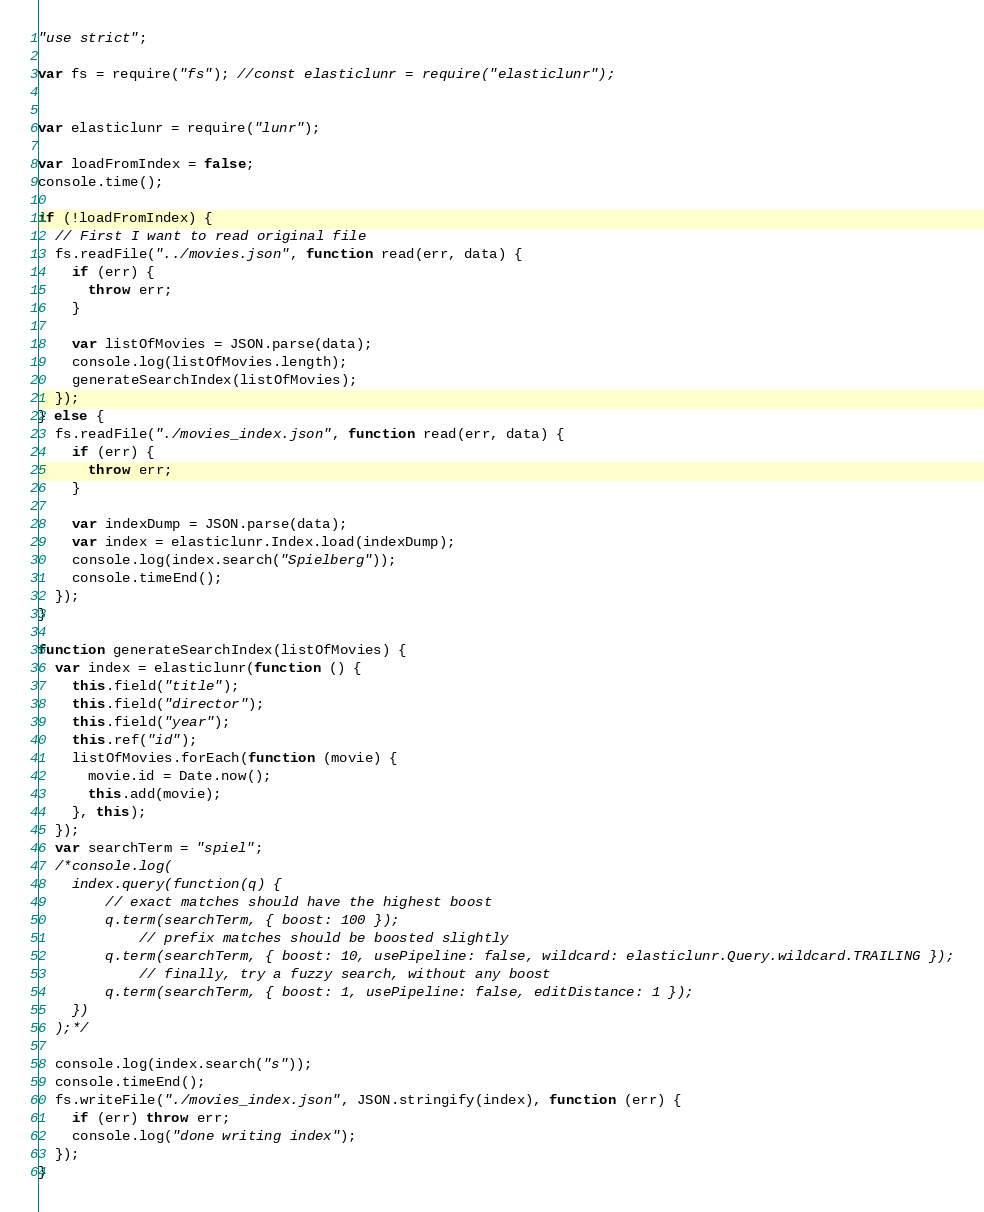Convert code to text. <code><loc_0><loc_0><loc_500><loc_500><_JavaScript_>"use strict";

var fs = require("fs"); //const elasticlunr = require("elasticlunr");


var elasticlunr = require("lunr");

var loadFromIndex = false;
console.time();

if (!loadFromIndex) {
  // First I want to read original file
  fs.readFile("../movies.json", function read(err, data) {
    if (err) {
      throw err;
    }

    var listOfMovies = JSON.parse(data);
    console.log(listOfMovies.length);
    generateSearchIndex(listOfMovies);
  });
} else {
  fs.readFile("./movies_index.json", function read(err, data) {
    if (err) {
      throw err;
    }

    var indexDump = JSON.parse(data);
    var index = elasticlunr.Index.load(indexDump);
    console.log(index.search("Spielberg"));
    console.timeEnd();
  });
}

function generateSearchIndex(listOfMovies) {
  var index = elasticlunr(function () {
    this.field("title");
    this.field("director");
    this.field("year");
    this.ref("id");
    listOfMovies.forEach(function (movie) {
      movie.id = Date.now();
      this.add(movie);
    }, this);
  });
  var searchTerm = "spiel";
  /*console.log(
  	index.query(function(q) {
  		// exact matches should have the highest boost
  		q.term(searchTerm, { boost: 100 });
  			// prefix matches should be boosted slightly
  		q.term(searchTerm, { boost: 10, usePipeline: false, wildcard: elasticlunr.Query.wildcard.TRAILING });
  			// finally, try a fuzzy search, without any boost
  		q.term(searchTerm, { boost: 1, usePipeline: false, editDistance: 1 });
  	})
  );*/

  console.log(index.search("s"));
  console.timeEnd();
  fs.writeFile("./movies_index.json", JSON.stringify(index), function (err) {
    if (err) throw err;
    console.log("done writing index");
  });
}</code> 